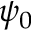Convert formula to latex. <formula><loc_0><loc_0><loc_500><loc_500>\psi _ { 0 }</formula> 